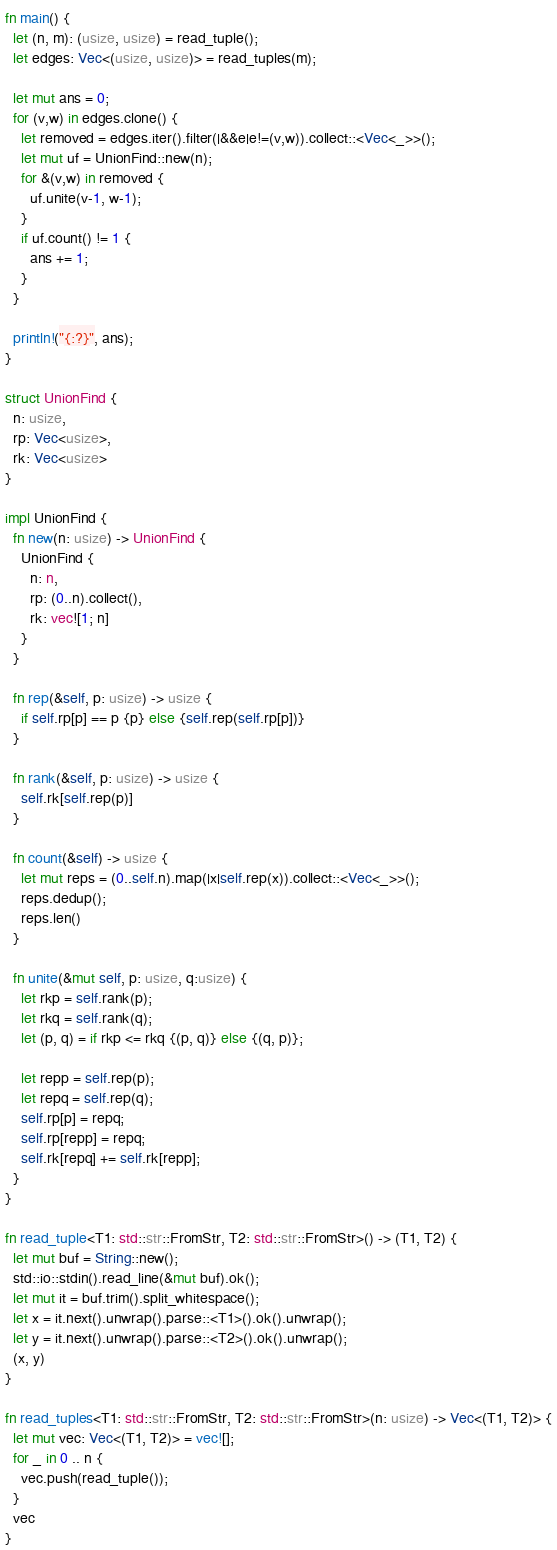Convert code to text. <code><loc_0><loc_0><loc_500><loc_500><_Rust_>fn main() {
  let (n, m): (usize, usize) = read_tuple();
  let edges: Vec<(usize, usize)> = read_tuples(m);
  
  let mut ans = 0;
  for (v,w) in edges.clone() {
    let removed = edges.iter().filter(|&&e|e!=(v,w)).collect::<Vec<_>>();
    let mut uf = UnionFind::new(n);
    for &(v,w) in removed {
      uf.unite(v-1, w-1);
    }
    if uf.count() != 1 {
      ans += 1;
    }
  }
  
  println!("{:?}", ans);
}

struct UnionFind {
  n: usize,
  rp: Vec<usize>,
  rk: Vec<usize>
}

impl UnionFind {
  fn new(n: usize) -> UnionFind {
    UnionFind {
      n: n,
      rp: (0..n).collect(),
      rk: vec![1; n]
    }
  }

  fn rep(&self, p: usize) -> usize {
    if self.rp[p] == p {p} else {self.rep(self.rp[p])}
  }

  fn rank(&self, p: usize) -> usize {
    self.rk[self.rep(p)]
  }

  fn count(&self) -> usize {
    let mut reps = (0..self.n).map(|x|self.rep(x)).collect::<Vec<_>>();
    reps.dedup();
    reps.len()
  }
  
  fn unite(&mut self, p: usize, q:usize) {
    let rkp = self.rank(p);
    let rkq = self.rank(q);
    let (p, q) = if rkp <= rkq {(p, q)} else {(q, p)};

    let repp = self.rep(p);
    let repq = self.rep(q);
    self.rp[p] = repq;
    self.rp[repp] = repq;
    self.rk[repq] += self.rk[repp];
  }
}       

fn read_tuple<T1: std::str::FromStr, T2: std::str::FromStr>() -> (T1, T2) {
  let mut buf = String::new();
  std::io::stdin().read_line(&mut buf).ok();
  let mut it = buf.trim().split_whitespace();
  let x = it.next().unwrap().parse::<T1>().ok().unwrap();
  let y = it.next().unwrap().parse::<T2>().ok().unwrap();
  (x, y)
}

fn read_tuples<T1: std::str::FromStr, T2: std::str::FromStr>(n: usize) -> Vec<(T1, T2)> {
  let mut vec: Vec<(T1, T2)> = vec![];
  for _ in 0 .. n {
    vec.push(read_tuple());
  }
  vec
}</code> 